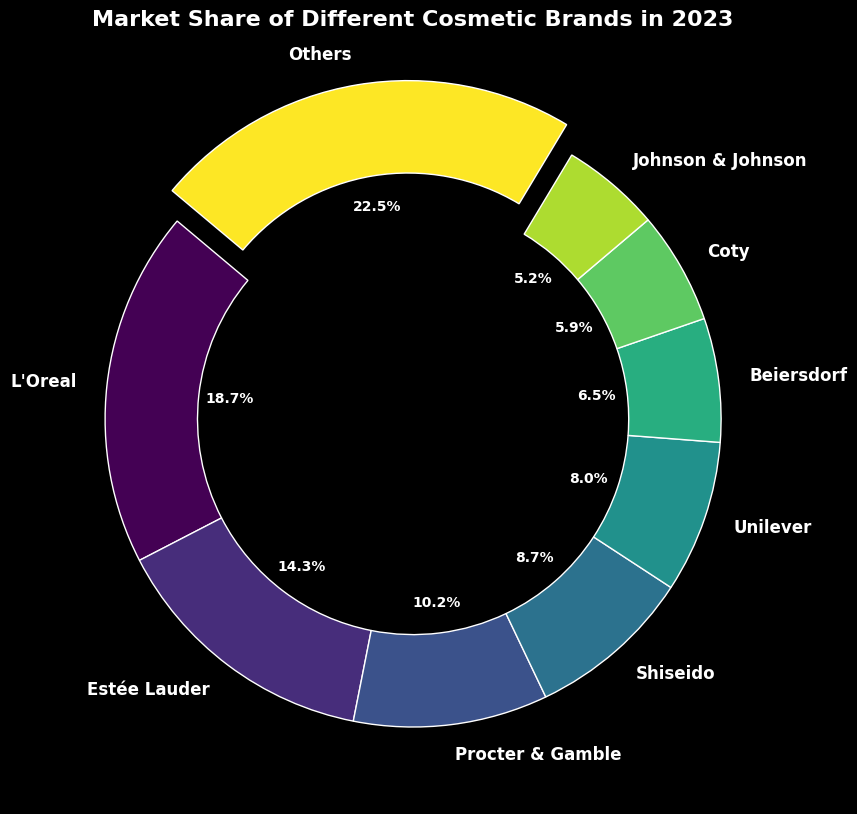Which brand has the highest market share? The brand with the highest percentage indicated on the pie chart is the one with the largest wedge and an exploded segment. Looking at the figure, we can see that L'Oreal has the largest wedge and is also the only exploded segment.
Answer: L'Oreal What is the total market share of Estée Lauder and Shiseido? Sum the market share percentages of Estée Lauder (14.3%) and Shiseido (8.7%). So, 14.3 + 8.7 = 23.0%.
Answer: 23.0% How much more market share does L'Oreal have compared to Johnson & Johnson? Subtract Johnson & Johnson's market share (5.2%) from L'Oreal's market share (18.7%). That is 18.7 - 5.2 = 13.5%.
Answer: 13.5% Which brands have market shares less than 10%? Look at the wedges in the pie chart and identify brands with percentages under 10%. These are Procter & Gamble, Shiseido, Unilever, Beiersdorf, Coty, and Johnson & Johnson.
Answer: Procter & Gamble, Shiseido, Unilever, Beiersdorf, Coty, Johnson & Johnson What is the difference in market share between the highest and lowest brand? Find the market share of L'Oreal (18.7%) and Johnson & Johnson (5.2%), then subtract the smallest from the largest: 18.7 - 5.2 = 13.5%.
Answer: 13.5% How many brands have a market share of over 10%? Count the number of wedges with market share percentages greater than 10%. These are L'Oreal (18.7%), Estée Lauder (14.3%), and Procter & Gamble (10.2%).
Answer: 3 What is the combined market share of Unilever and Coty? Sum the market shares of Unilever (8.0%) and Coty (5.9%). So, 8.0 + 5.9 = 13.9%.
Answer: 13.9% What is the average market share of L'Oreal, Estée Lauder, and Procter & Gamble? Calculate the average of their market shares: (18.7 + 14.3 + 10.2) / 3 = 14.4%.
Answer: 14.4% Which brand has the smallest market share and what is its percentage? Locate the smallest wedge in the pie chart which represents the brand with the smallest market share, identified as Johnson & Johnson with 5.2%.
Answer: Johnson & Johnson, 5.2% Compare the market shares of Unilever and Beiersdorf. Which is larger and by how much? Identify Unilever's share (8.0%) and Beiersdorf's share (6.5%), then find the difference: 8.0 - 6.5 = 1.5%. Unilever has the larger share.
Answer: Unilever, 1.5% 